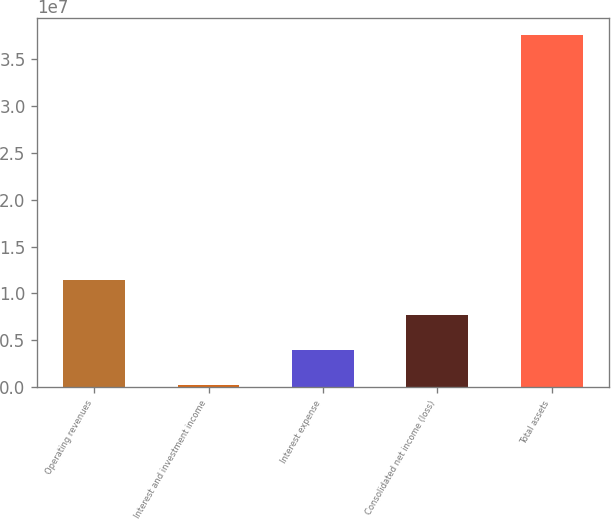Convert chart. <chart><loc_0><loc_0><loc_500><loc_500><bar_chart><fcel>Operating revenues<fcel>Interest and investment income<fcel>Interest expense<fcel>Consolidated net income (loss)<fcel>Total assets<nl><fcel>1.14342e+07<fcel>236628<fcel>3.96916e+06<fcel>7.70169e+06<fcel>3.7562e+07<nl></chart> 